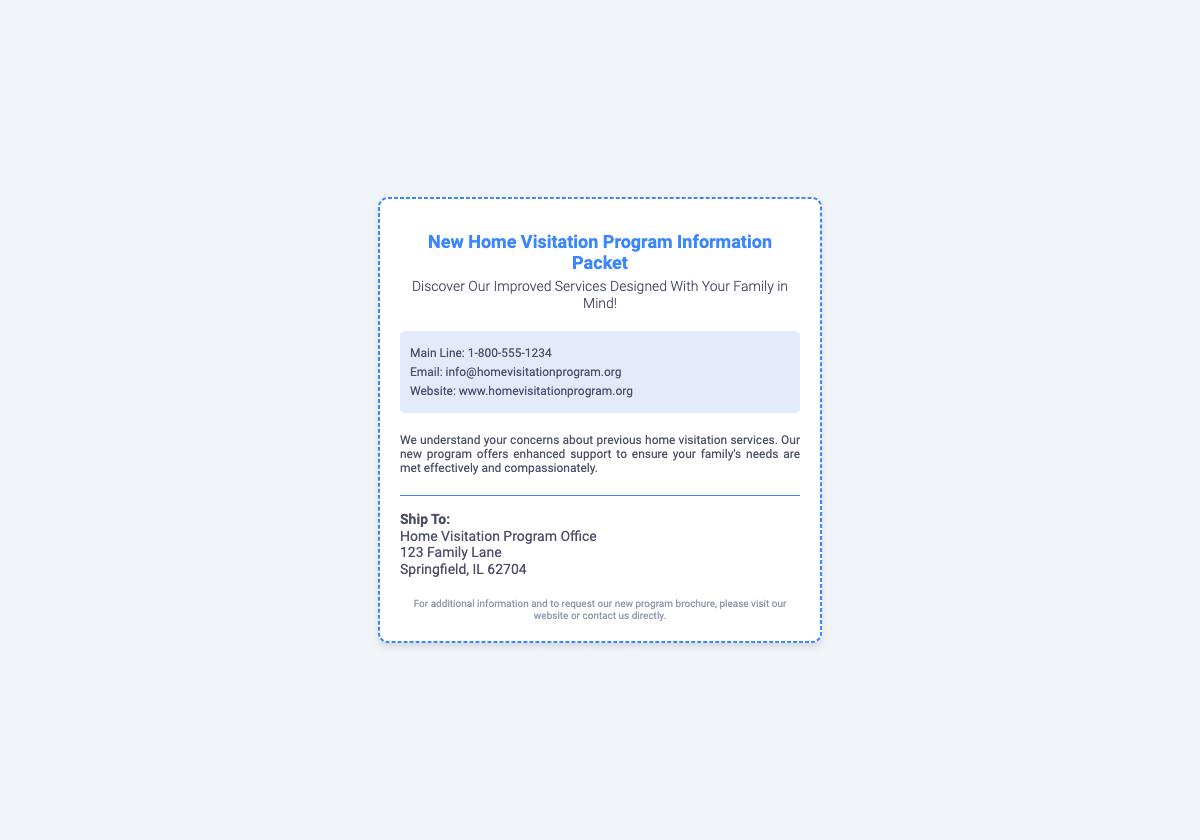What is the title of the document? The title of the document is displayed prominently at the top of the shipping label.
Answer: New Home Visitation Program Information Packet What is the contact email provided? The document includes a contact email in the contact information section.
Answer: info@homevisitationprogram.org What is the main line phone number? The document lists a main line phone number for inquiries.
Answer: 1-800-555-1234 What street is the Home Visitation Program office located on? The document specifies the street address of the office in the shipping label.
Answer: 123 Family Lane What is the purpose of the program mentioned? The description section highlights the program's intent to assist families.
Answer: Enhanced support What type of information can be requested from the website? The footer notes additional information and brochure requests are available through the website.
Answer: Brochure What city is the program office located in? The address section of the document indicates the city of the program office.
Answer: Springfield What color is the border of the shipping label? The style of the shipping label is defined by the visual design elements in the document.
Answer: Dashed blue 